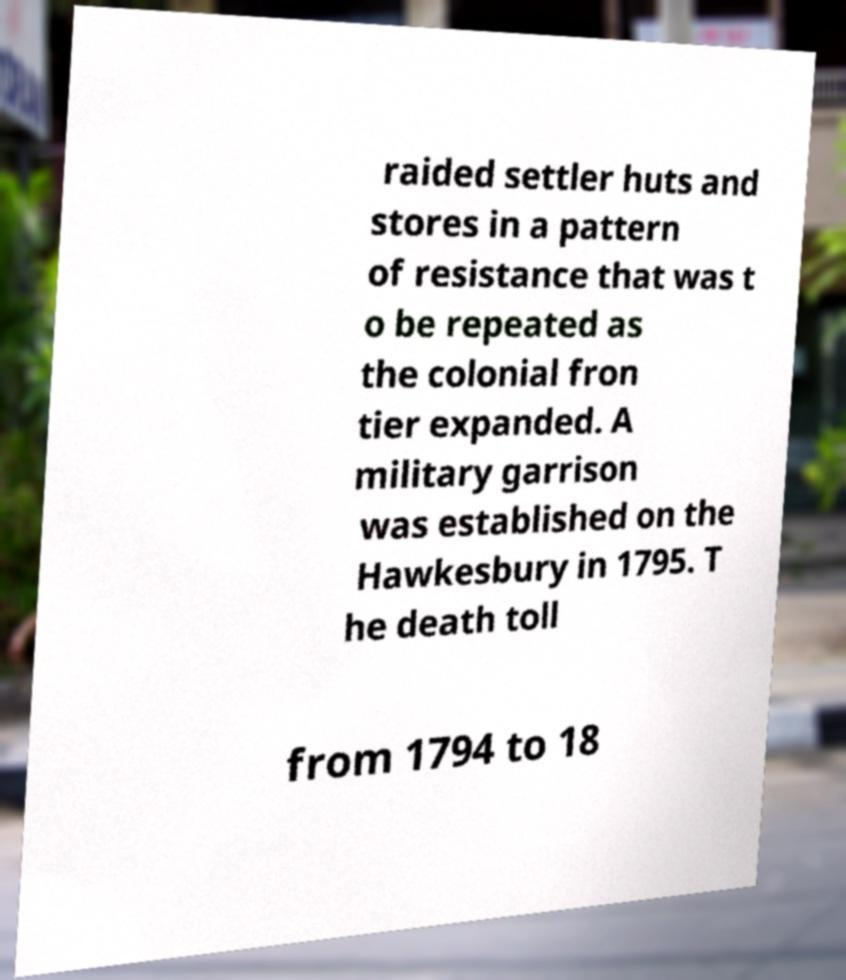Please identify and transcribe the text found in this image. raided settler huts and stores in a pattern of resistance that was t o be repeated as the colonial fron tier expanded. A military garrison was established on the Hawkesbury in 1795. T he death toll from 1794 to 18 